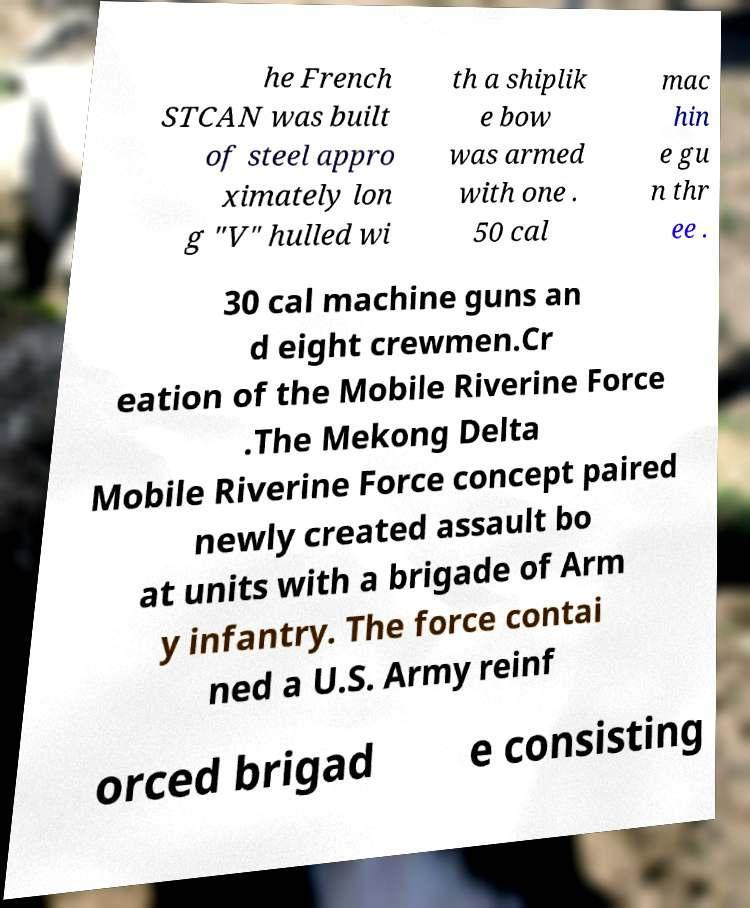What messages or text are displayed in this image? I need them in a readable, typed format. he French STCAN was built of steel appro ximately lon g "V" hulled wi th a shiplik e bow was armed with one . 50 cal mac hin e gu n thr ee . 30 cal machine guns an d eight crewmen.Cr eation of the Mobile Riverine Force .The Mekong Delta Mobile Riverine Force concept paired newly created assault bo at units with a brigade of Arm y infantry. The force contai ned a U.S. Army reinf orced brigad e consisting 